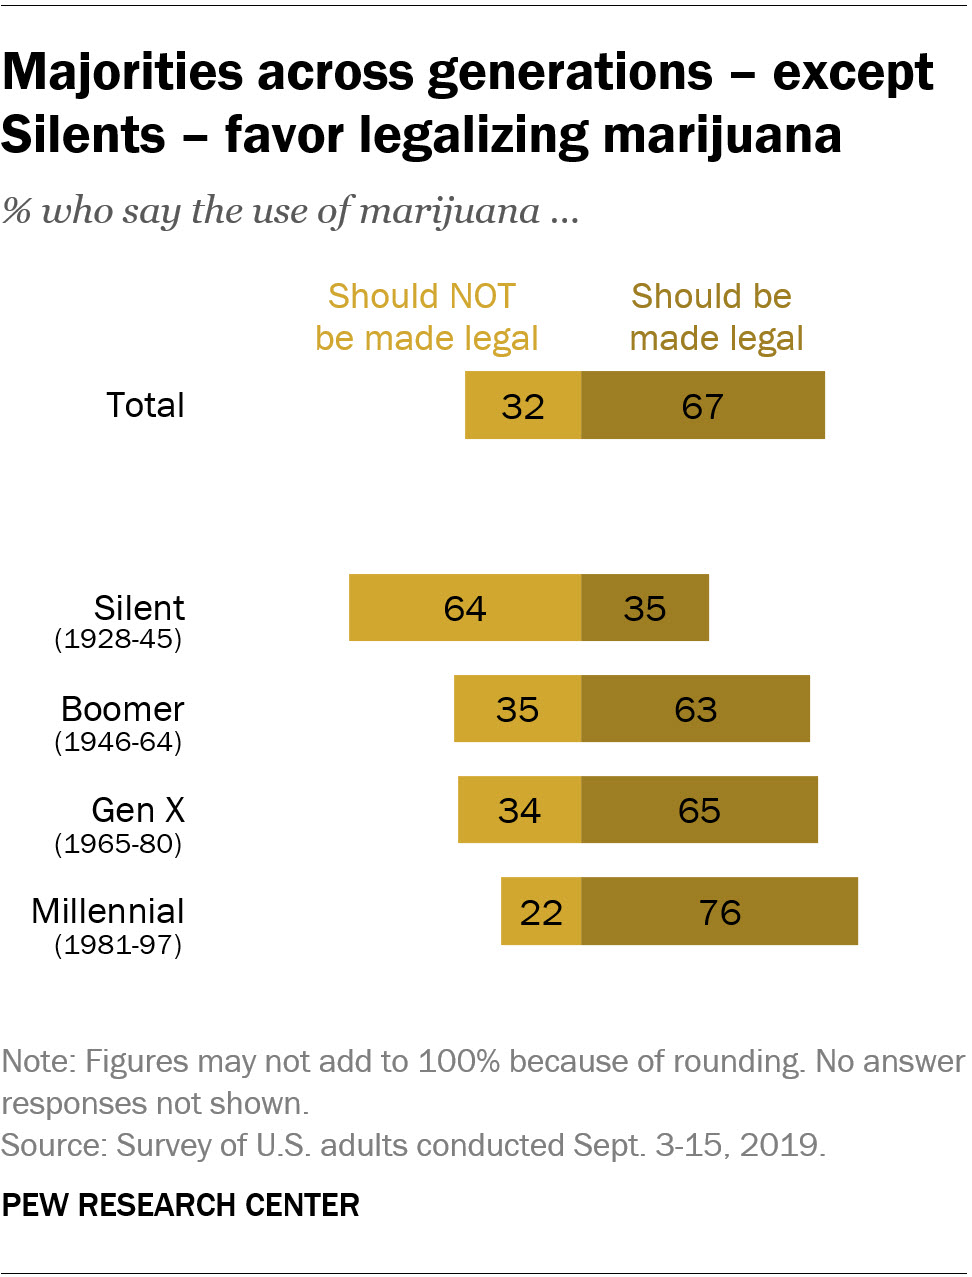Outline some significant characteristics in this image. According to a survey, 67% of people favor the legalization of marijuana. The generation of Gen X (1965-80) and Millennials (1981-97) have the widest gap when it comes to their stances on legalizing marijuana, with those who favor it outnumbering those who oppose it. 